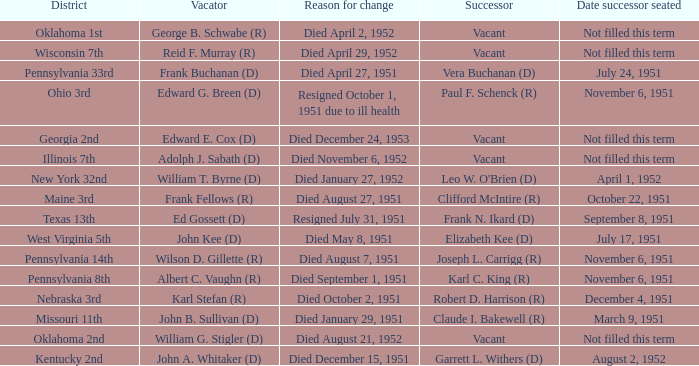How many vacators were in the Pennsylvania 33rd district? 1.0. 